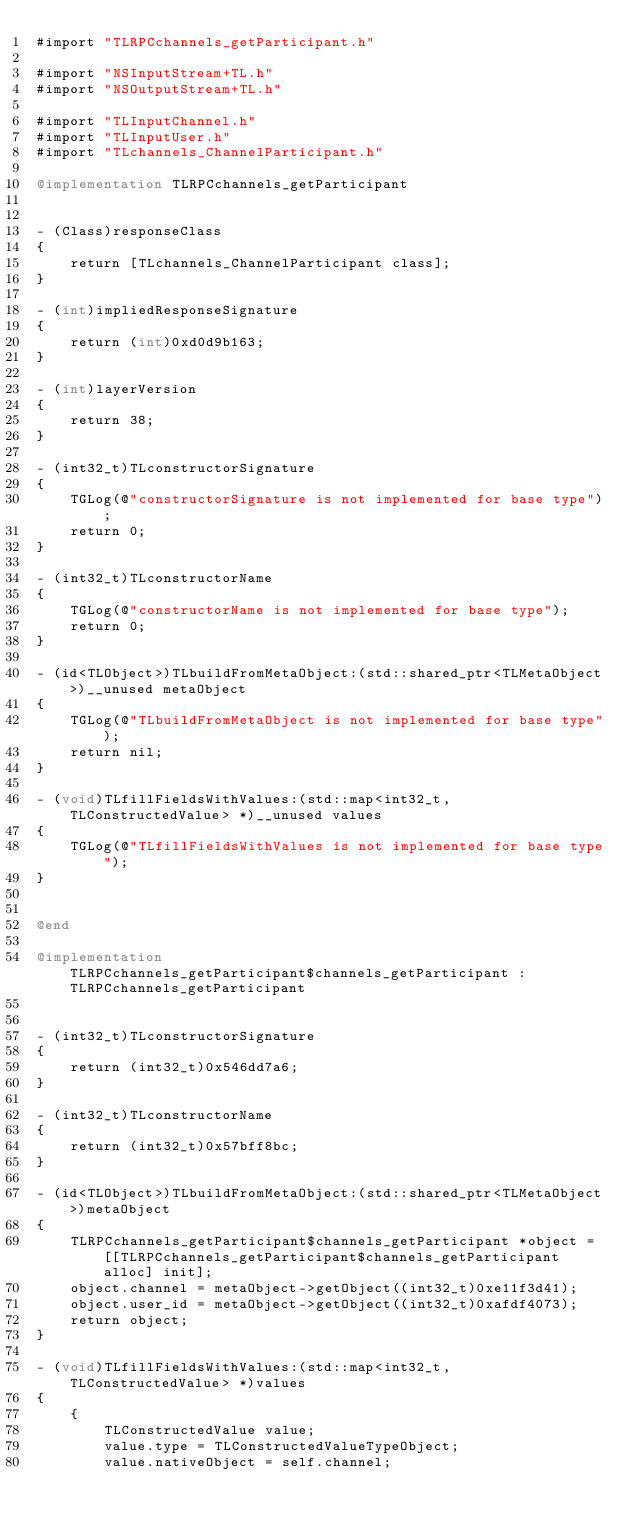<code> <loc_0><loc_0><loc_500><loc_500><_ObjectiveC_>#import "TLRPCchannels_getParticipant.h"

#import "NSInputStream+TL.h"
#import "NSOutputStream+TL.h"

#import "TLInputChannel.h"
#import "TLInputUser.h"
#import "TLchannels_ChannelParticipant.h"

@implementation TLRPCchannels_getParticipant


- (Class)responseClass
{
    return [TLchannels_ChannelParticipant class];
}

- (int)impliedResponseSignature
{
    return (int)0xd0d9b163;
}

- (int)layerVersion
{
    return 38;
}

- (int32_t)TLconstructorSignature
{
    TGLog(@"constructorSignature is not implemented for base type");
    return 0;
}

- (int32_t)TLconstructorName
{
    TGLog(@"constructorName is not implemented for base type");
    return 0;
}

- (id<TLObject>)TLbuildFromMetaObject:(std::shared_ptr<TLMetaObject>)__unused metaObject
{
    TGLog(@"TLbuildFromMetaObject is not implemented for base type");
    return nil;
}

- (void)TLfillFieldsWithValues:(std::map<int32_t, TLConstructedValue> *)__unused values
{
    TGLog(@"TLfillFieldsWithValues is not implemented for base type");
}


@end

@implementation TLRPCchannels_getParticipant$channels_getParticipant : TLRPCchannels_getParticipant


- (int32_t)TLconstructorSignature
{
    return (int32_t)0x546dd7a6;
}

- (int32_t)TLconstructorName
{
    return (int32_t)0x57bff8bc;
}

- (id<TLObject>)TLbuildFromMetaObject:(std::shared_ptr<TLMetaObject>)metaObject
{
    TLRPCchannels_getParticipant$channels_getParticipant *object = [[TLRPCchannels_getParticipant$channels_getParticipant alloc] init];
    object.channel = metaObject->getObject((int32_t)0xe11f3d41);
    object.user_id = metaObject->getObject((int32_t)0xafdf4073);
    return object;
}

- (void)TLfillFieldsWithValues:(std::map<int32_t, TLConstructedValue> *)values
{
    {
        TLConstructedValue value;
        value.type = TLConstructedValueTypeObject;
        value.nativeObject = self.channel;</code> 